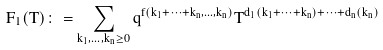<formula> <loc_0><loc_0><loc_500><loc_500>F _ { 1 } ( T ) \colon = \sum _ { k _ { 1 } , \dots , k _ { n } \geq 0 } q ^ { f ( k _ { 1 } + \cdots + k _ { n } , \dots , k _ { n } ) } T ^ { d _ { 1 } ( k _ { 1 } + \cdots + k _ { n } ) + \cdots + d _ { n } ( k _ { n } ) }</formula> 